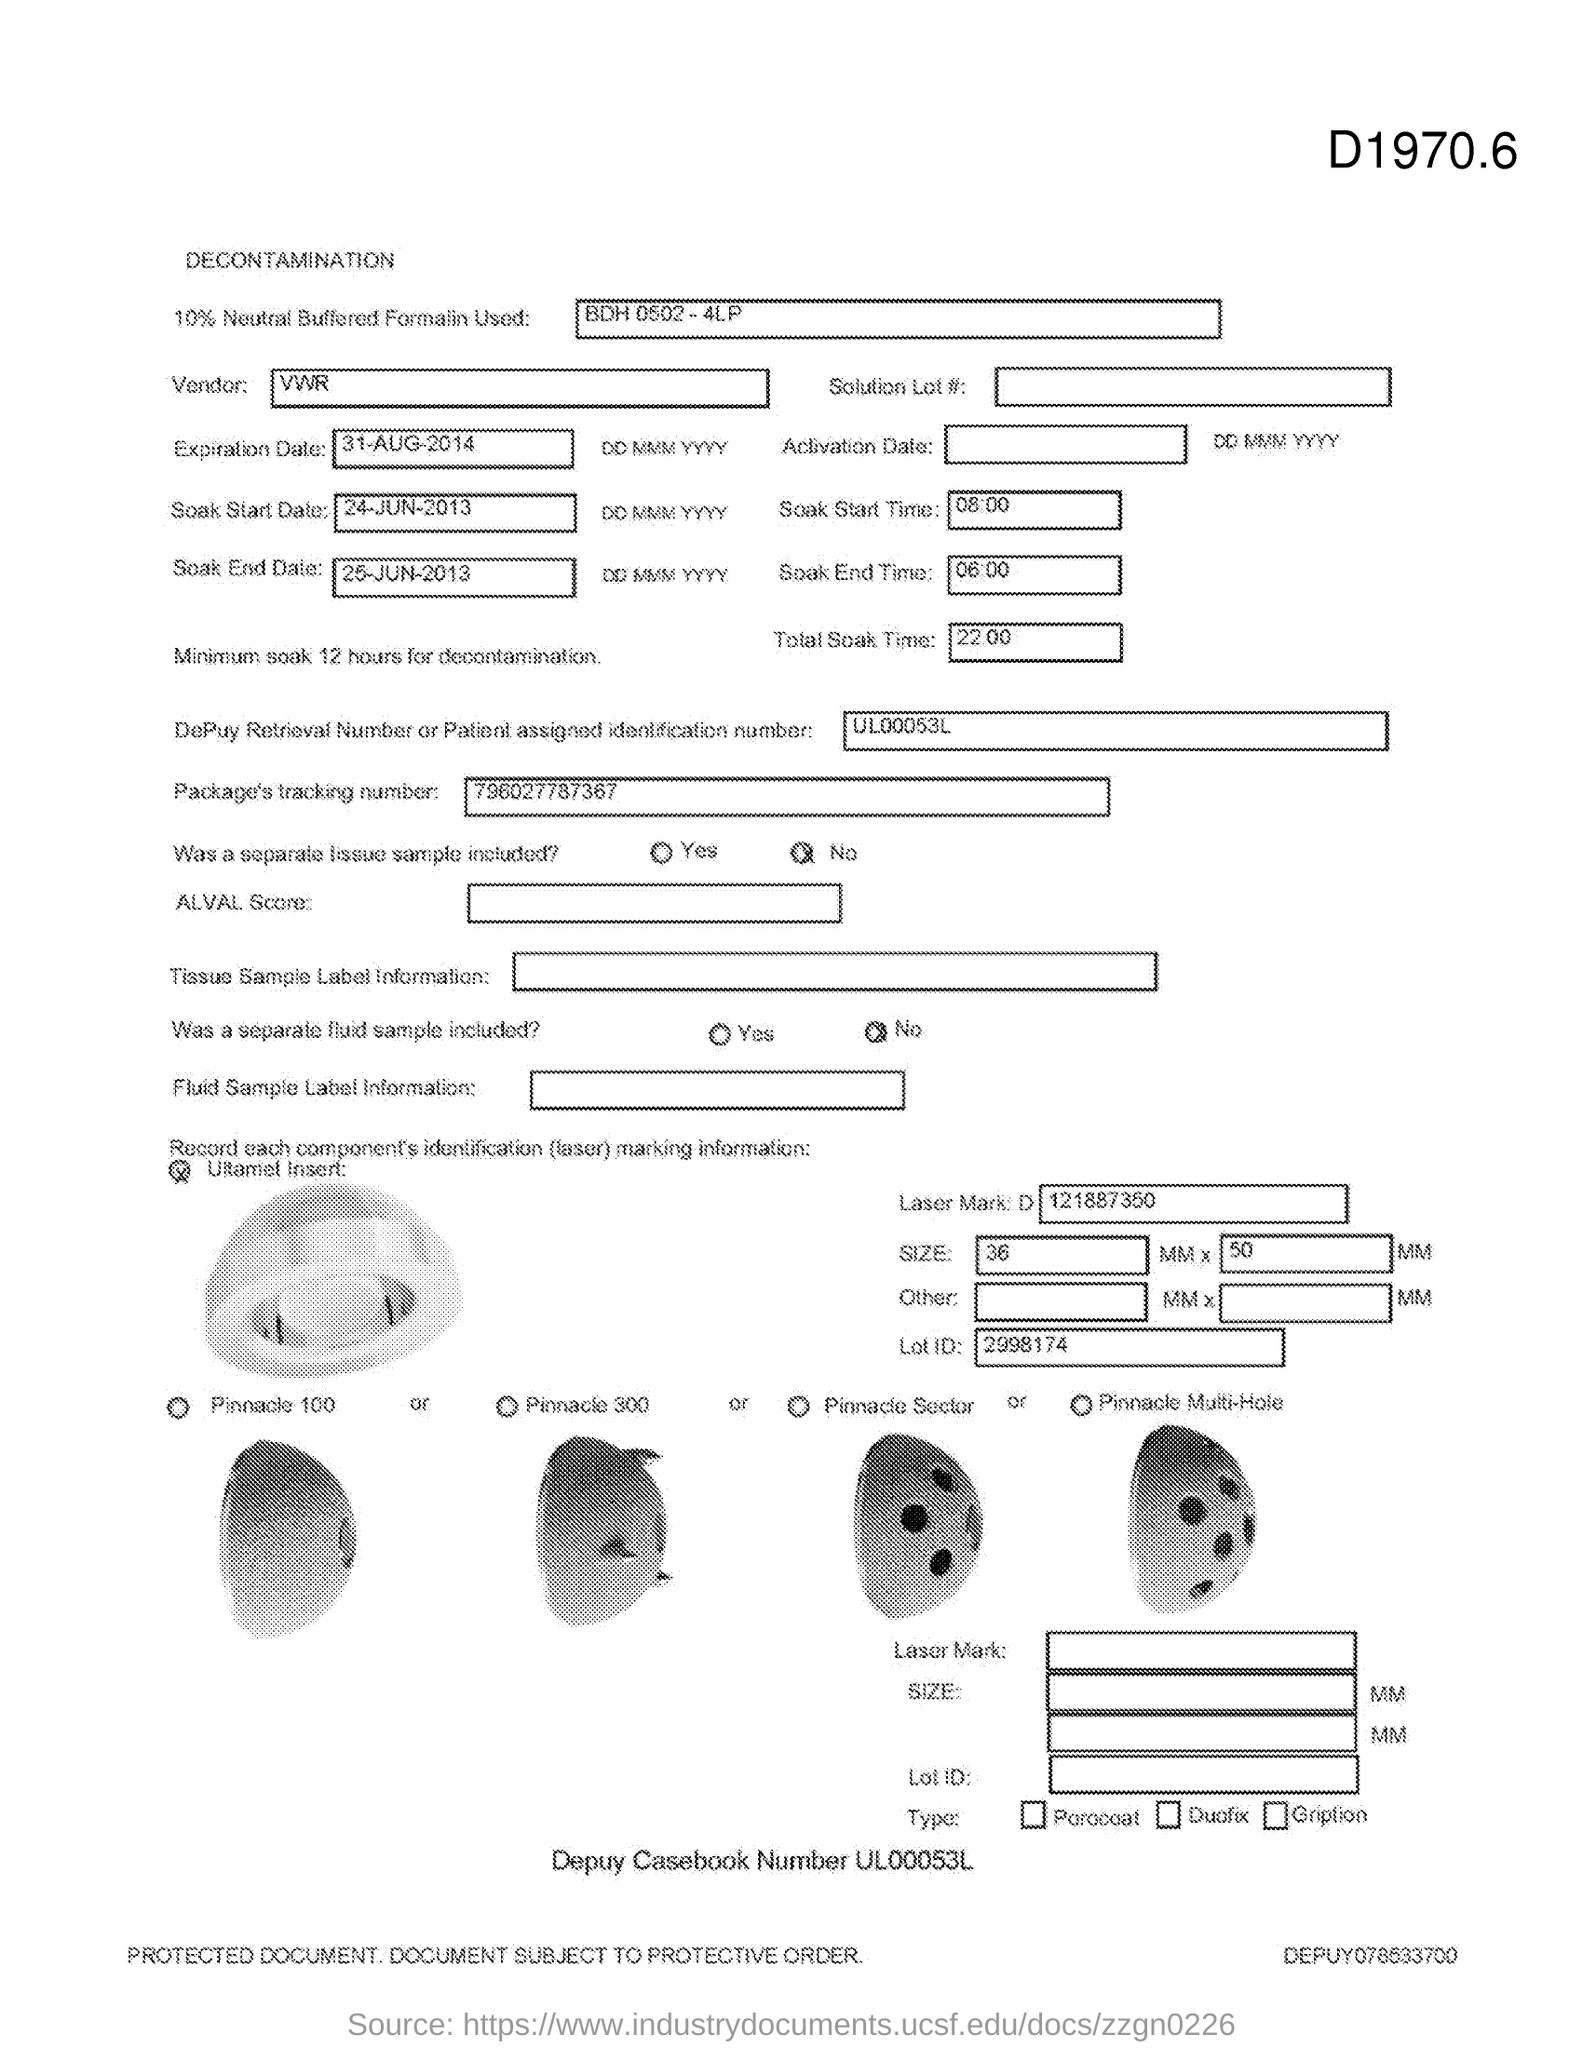Outline some significant characteristics in this image. The Soak Start Time is 08:00. The total soak time is 22 hours and 0 minutes. The soak end time is 06:00. 